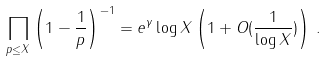<formula> <loc_0><loc_0><loc_500><loc_500>\prod _ { p \leq X } \left ( 1 - \frac { 1 } { p } \right ) ^ { - 1 } = e ^ { \gamma } \log X \left ( 1 + O ( \frac { 1 } { \log X } ) \right ) \, .</formula> 